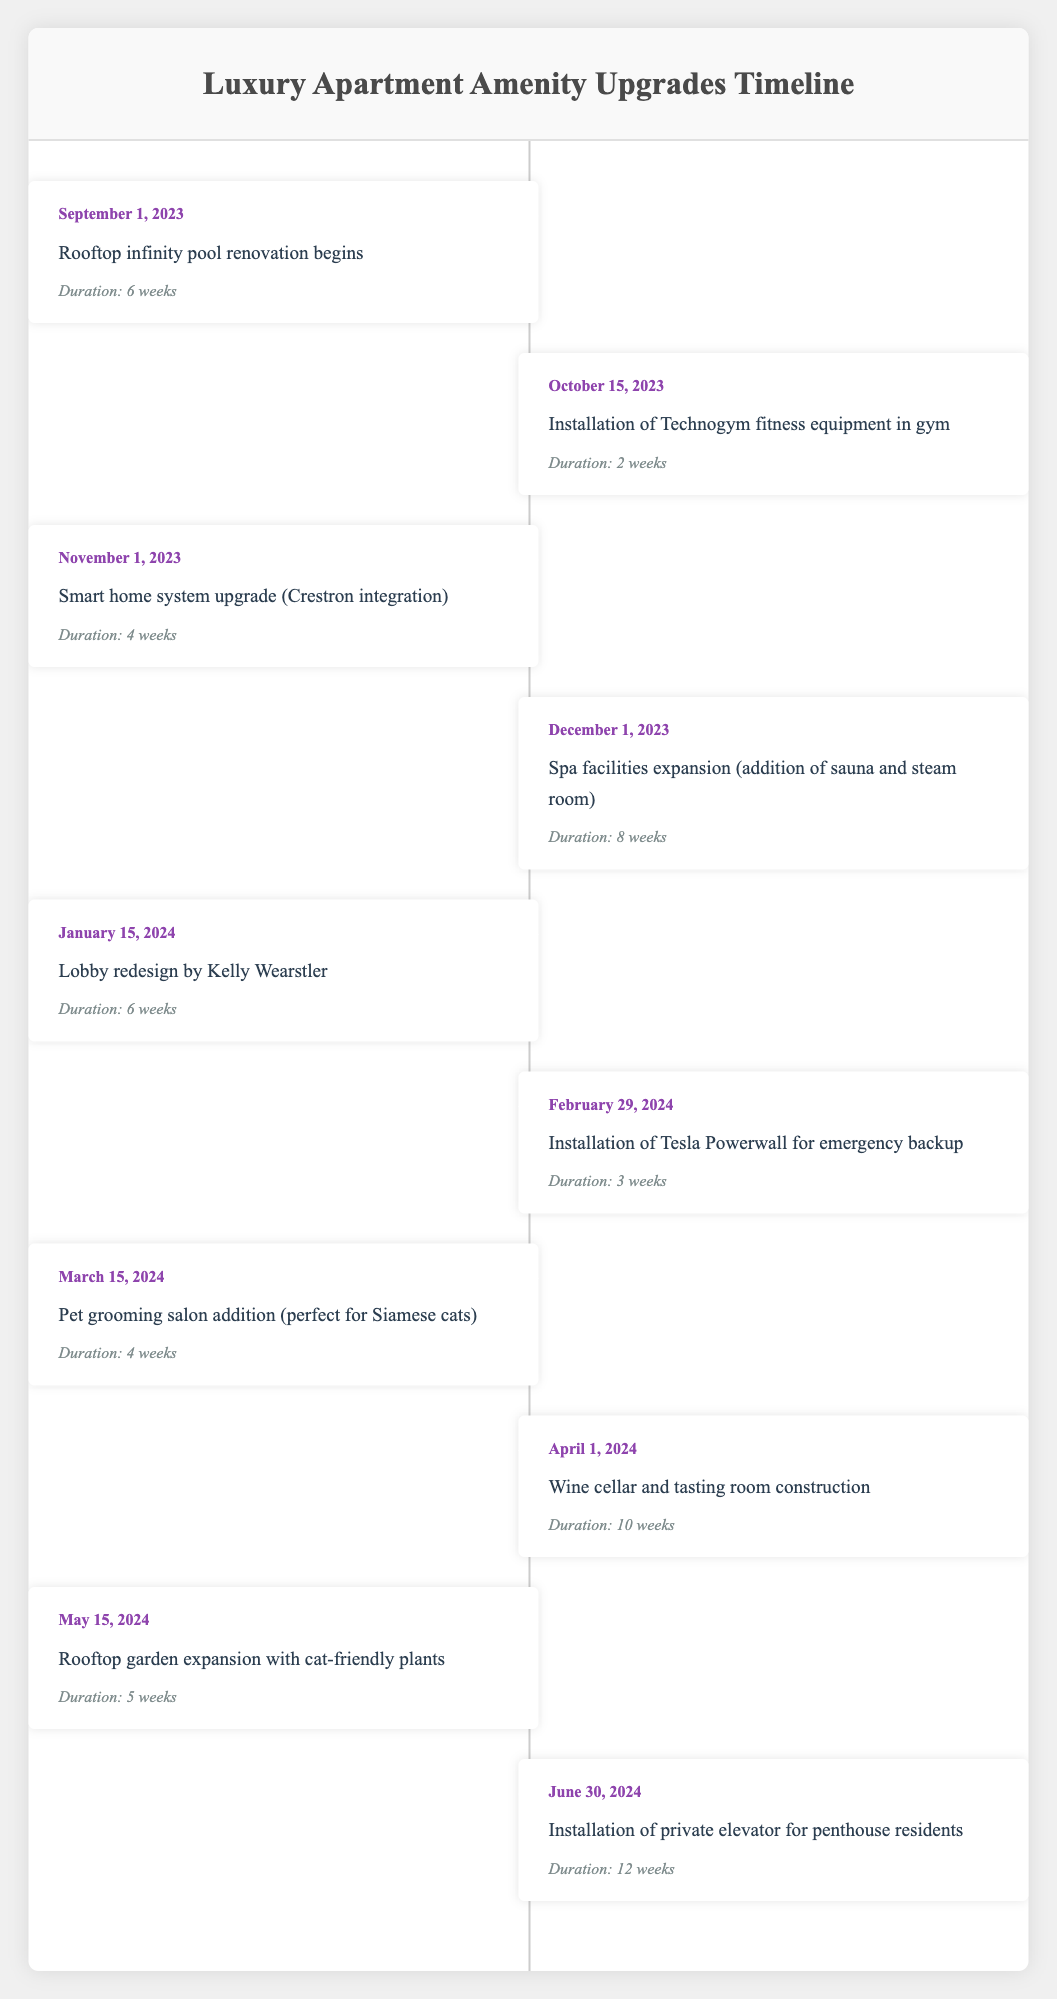What is the date when the rooftop infinity pool renovation begins? The start date for the rooftop infinity pool renovation is clearly stated in the table under the event for "Rooftop infinity pool renovation begins." The date listed there is September 1, 2023.
Answer: September 1, 2023 How long will the spa facilities expansion take? The duration for the spa facilities expansion (which includes the addition of a sauna and steam room) is provided in the table. It states that this event will take 8 weeks.
Answer: 8 weeks Which event is scheduled to occur right after the installation of Technogym fitness equipment? To find this out, we look for the event that follows the "Installation of Technogym fitness equipment in gym," which starts on October 15, 2023. The next event listed is "Smart home system upgrade (Crestron integration)" starting on November 1, 2023.
Answer: Smart home system upgrade (Crestron integration) How much time will pass between the completion of the pet grooming salon addition and the installation of the private elevator? The pet grooming salon addition is scheduled to finish on April 12, 2024 (starting on March 15, 2024, for 4 weeks), and the private elevator installation starts on June 30, 2024. Calculating the time difference, we have from April 12 to June 30 is 79 days, which can also be broken down to approximately 11 weeks and 2 days.
Answer: Approximately 11 weeks and 2 days Is there an event scheduled for the installation of Tesla Powerwall before March 15, 2024? According to the table, the installation of Tesla Powerwall is scheduled to start on February 29, 2024, which is before March 15, 2024. Therefore, the answer to the question is yes.
Answer: Yes What is the total duration of the rooftop garden expansion and wine cellar construction combined? The duration of the rooftop garden expansion is 5 weeks, and the wine cellar construction lasts 10 weeks. Adding these together gives us a total duration of 15 weeks for both events.
Answer: 15 weeks Which event will take the longest according to the schedule? To answer this, we scan through all the durations listed in the table. The longest duration is for the installation of the private elevator, which is 12 weeks long.
Answer: Installation of private elevator for penthouse residents Will the lobby redesign occur before the installation of the Tesla Powerwall? The lobby redesign is scheduled to start on January 15, 2024, while the Tesla Powerwall installation starts on February 29, 2024. Since January 15 is before February 29, the answer is yes.
Answer: Yes 